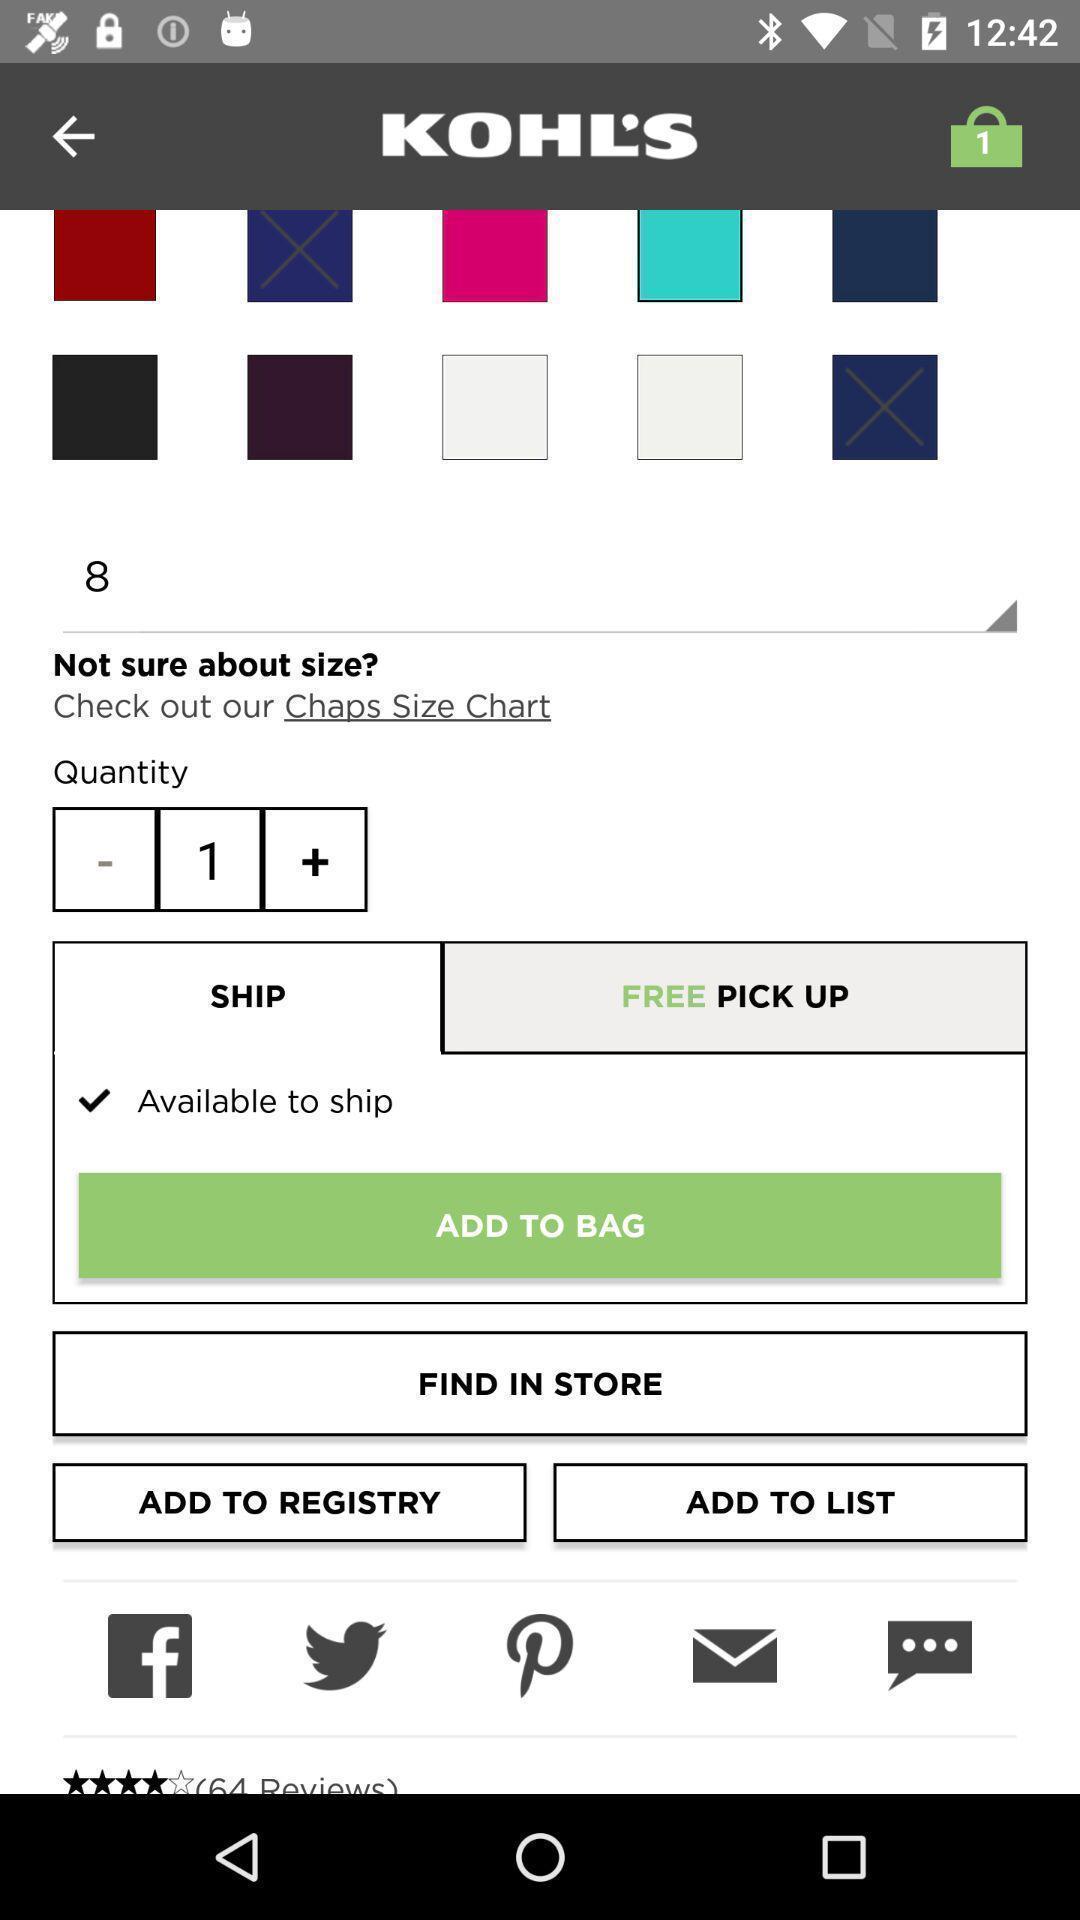Describe this image in words. Screen page of a shopping application. 